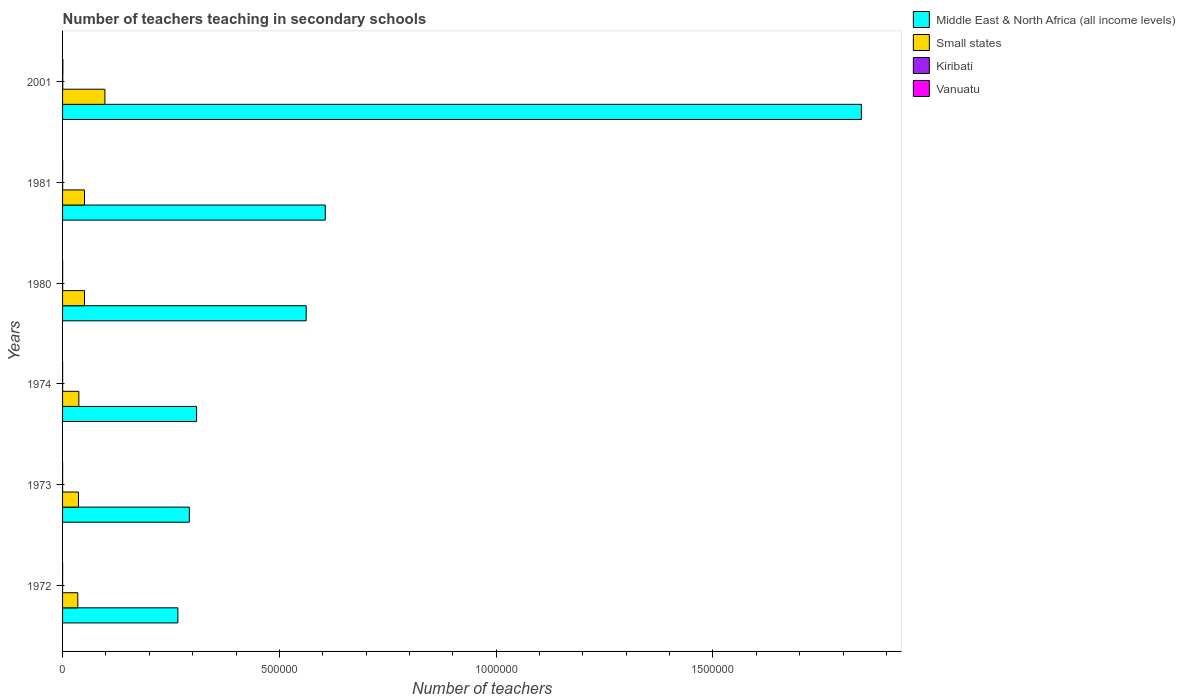How many different coloured bars are there?
Provide a short and direct response. 4. How many bars are there on the 5th tick from the bottom?
Your answer should be compact. 4. In how many cases, is the number of bars for a given year not equal to the number of legend labels?
Ensure brevity in your answer.  0. What is the number of teachers teaching in secondary schools in Middle East & North Africa (all income levels) in 1981?
Give a very brief answer. 6.06e+05. Across all years, what is the maximum number of teachers teaching in secondary schools in Middle East & North Africa (all income levels)?
Make the answer very short. 1.84e+06. Across all years, what is the minimum number of teachers teaching in secondary schools in Small states?
Offer a terse response. 3.51e+04. In which year was the number of teachers teaching in secondary schools in Kiribati minimum?
Offer a very short reply. 1972. What is the total number of teachers teaching in secondary schools in Middle East & North Africa (all income levels) in the graph?
Provide a short and direct response. 3.88e+06. What is the difference between the number of teachers teaching in secondary schools in Kiribati in 1972 and that in 1974?
Give a very brief answer. -10. What is the average number of teachers teaching in secondary schools in Middle East & North Africa (all income levels) per year?
Give a very brief answer. 6.46e+05. In the year 1980, what is the difference between the number of teachers teaching in secondary schools in Vanuatu and number of teachers teaching in secondary schools in Middle East & North Africa (all income levels)?
Ensure brevity in your answer.  -5.62e+05. What is the ratio of the number of teachers teaching in secondary schools in Kiribati in 1972 to that in 1980?
Keep it short and to the point. 0.53. Is the difference between the number of teachers teaching in secondary schools in Vanuatu in 1973 and 1974 greater than the difference between the number of teachers teaching in secondary schools in Middle East & North Africa (all income levels) in 1973 and 1974?
Ensure brevity in your answer.  Yes. What is the difference between the highest and the second highest number of teachers teaching in secondary schools in Middle East & North Africa (all income levels)?
Your answer should be compact. 1.24e+06. What is the difference between the highest and the lowest number of teachers teaching in secondary schools in Kiribati?
Keep it short and to the point. 367. In how many years, is the number of teachers teaching in secondary schools in Middle East & North Africa (all income levels) greater than the average number of teachers teaching in secondary schools in Middle East & North Africa (all income levels) taken over all years?
Your answer should be very brief. 1. What does the 4th bar from the top in 1973 represents?
Keep it short and to the point. Middle East & North Africa (all income levels). What does the 4th bar from the bottom in 1972 represents?
Make the answer very short. Vanuatu. How many bars are there?
Your answer should be compact. 24. Are all the bars in the graph horizontal?
Your answer should be very brief. Yes. How many years are there in the graph?
Your answer should be compact. 6. What is the difference between two consecutive major ticks on the X-axis?
Keep it short and to the point. 5.00e+05. Does the graph contain any zero values?
Give a very brief answer. No. Where does the legend appear in the graph?
Offer a very short reply. Top right. How many legend labels are there?
Keep it short and to the point. 4. What is the title of the graph?
Give a very brief answer. Number of teachers teaching in secondary schools. Does "Ukraine" appear as one of the legend labels in the graph?
Provide a short and direct response. No. What is the label or title of the X-axis?
Offer a terse response. Number of teachers. What is the Number of teachers in Middle East & North Africa (all income levels) in 1972?
Ensure brevity in your answer.  2.66e+05. What is the Number of teachers in Small states in 1972?
Give a very brief answer. 3.51e+04. What is the Number of teachers in Kiribati in 1972?
Provide a short and direct response. 82. What is the Number of teachers of Vanuatu in 1972?
Provide a succinct answer. 113. What is the Number of teachers of Middle East & North Africa (all income levels) in 1973?
Ensure brevity in your answer.  2.92e+05. What is the Number of teachers in Small states in 1973?
Ensure brevity in your answer.  3.67e+04. What is the Number of teachers of Kiribati in 1973?
Your answer should be very brief. 82. What is the Number of teachers in Middle East & North Africa (all income levels) in 1974?
Make the answer very short. 3.09e+05. What is the Number of teachers in Small states in 1974?
Make the answer very short. 3.76e+04. What is the Number of teachers in Kiribati in 1974?
Provide a succinct answer. 92. What is the Number of teachers of Vanuatu in 1974?
Ensure brevity in your answer.  96. What is the Number of teachers of Middle East & North Africa (all income levels) in 1980?
Give a very brief answer. 5.62e+05. What is the Number of teachers of Small states in 1980?
Your answer should be very brief. 5.06e+04. What is the Number of teachers of Kiribati in 1980?
Your answer should be compact. 154. What is the Number of teachers of Vanuatu in 1980?
Offer a very short reply. 185. What is the Number of teachers of Middle East & North Africa (all income levels) in 1981?
Your response must be concise. 6.06e+05. What is the Number of teachers of Small states in 1981?
Provide a short and direct response. 5.06e+04. What is the Number of teachers of Kiribati in 1981?
Provide a short and direct response. 131. What is the Number of teachers of Vanuatu in 1981?
Make the answer very short. 188. What is the Number of teachers of Middle East & North Africa (all income levels) in 2001?
Your answer should be very brief. 1.84e+06. What is the Number of teachers of Small states in 2001?
Your answer should be compact. 9.76e+04. What is the Number of teachers of Kiribati in 2001?
Make the answer very short. 449. What is the Number of teachers of Vanuatu in 2001?
Offer a terse response. 722. Across all years, what is the maximum Number of teachers in Middle East & North Africa (all income levels)?
Provide a short and direct response. 1.84e+06. Across all years, what is the maximum Number of teachers in Small states?
Give a very brief answer. 9.76e+04. Across all years, what is the maximum Number of teachers of Kiribati?
Give a very brief answer. 449. Across all years, what is the maximum Number of teachers of Vanuatu?
Offer a very short reply. 722. Across all years, what is the minimum Number of teachers of Middle East & North Africa (all income levels)?
Provide a short and direct response. 2.66e+05. Across all years, what is the minimum Number of teachers in Small states?
Ensure brevity in your answer.  3.51e+04. Across all years, what is the minimum Number of teachers of Kiribati?
Your response must be concise. 82. What is the total Number of teachers of Middle East & North Africa (all income levels) in the graph?
Make the answer very short. 3.88e+06. What is the total Number of teachers of Small states in the graph?
Provide a short and direct response. 3.08e+05. What is the total Number of teachers in Kiribati in the graph?
Keep it short and to the point. 990. What is the total Number of teachers of Vanuatu in the graph?
Give a very brief answer. 1394. What is the difference between the Number of teachers of Middle East & North Africa (all income levels) in 1972 and that in 1973?
Offer a terse response. -2.65e+04. What is the difference between the Number of teachers of Small states in 1972 and that in 1973?
Make the answer very short. -1541.71. What is the difference between the Number of teachers in Middle East & North Africa (all income levels) in 1972 and that in 1974?
Give a very brief answer. -4.32e+04. What is the difference between the Number of teachers in Small states in 1972 and that in 1974?
Provide a succinct answer. -2455.04. What is the difference between the Number of teachers in Kiribati in 1972 and that in 1974?
Provide a short and direct response. -10. What is the difference between the Number of teachers of Middle East & North Africa (all income levels) in 1972 and that in 1980?
Provide a short and direct response. -2.96e+05. What is the difference between the Number of teachers in Small states in 1972 and that in 1980?
Provide a short and direct response. -1.54e+04. What is the difference between the Number of teachers in Kiribati in 1972 and that in 1980?
Keep it short and to the point. -72. What is the difference between the Number of teachers of Vanuatu in 1972 and that in 1980?
Make the answer very short. -72. What is the difference between the Number of teachers in Middle East & North Africa (all income levels) in 1972 and that in 1981?
Offer a very short reply. -3.40e+05. What is the difference between the Number of teachers in Small states in 1972 and that in 1981?
Offer a very short reply. -1.55e+04. What is the difference between the Number of teachers of Kiribati in 1972 and that in 1981?
Provide a succinct answer. -49. What is the difference between the Number of teachers in Vanuatu in 1972 and that in 1981?
Your answer should be compact. -75. What is the difference between the Number of teachers in Middle East & North Africa (all income levels) in 1972 and that in 2001?
Keep it short and to the point. -1.58e+06. What is the difference between the Number of teachers of Small states in 1972 and that in 2001?
Your response must be concise. -6.25e+04. What is the difference between the Number of teachers in Kiribati in 1972 and that in 2001?
Offer a terse response. -367. What is the difference between the Number of teachers of Vanuatu in 1972 and that in 2001?
Provide a short and direct response. -609. What is the difference between the Number of teachers in Middle East & North Africa (all income levels) in 1973 and that in 1974?
Ensure brevity in your answer.  -1.67e+04. What is the difference between the Number of teachers in Small states in 1973 and that in 1974?
Your answer should be very brief. -913.34. What is the difference between the Number of teachers of Kiribati in 1973 and that in 1974?
Your answer should be very brief. -10. What is the difference between the Number of teachers in Middle East & North Africa (all income levels) in 1973 and that in 1980?
Your answer should be very brief. -2.69e+05. What is the difference between the Number of teachers of Small states in 1973 and that in 1980?
Provide a short and direct response. -1.39e+04. What is the difference between the Number of teachers of Kiribati in 1973 and that in 1980?
Provide a succinct answer. -72. What is the difference between the Number of teachers in Vanuatu in 1973 and that in 1980?
Your answer should be compact. -95. What is the difference between the Number of teachers of Middle East & North Africa (all income levels) in 1973 and that in 1981?
Your answer should be compact. -3.13e+05. What is the difference between the Number of teachers in Small states in 1973 and that in 1981?
Make the answer very short. -1.39e+04. What is the difference between the Number of teachers of Kiribati in 1973 and that in 1981?
Provide a short and direct response. -49. What is the difference between the Number of teachers of Vanuatu in 1973 and that in 1981?
Keep it short and to the point. -98. What is the difference between the Number of teachers in Middle East & North Africa (all income levels) in 1973 and that in 2001?
Your response must be concise. -1.55e+06. What is the difference between the Number of teachers of Small states in 1973 and that in 2001?
Offer a terse response. -6.10e+04. What is the difference between the Number of teachers in Kiribati in 1973 and that in 2001?
Offer a terse response. -367. What is the difference between the Number of teachers in Vanuatu in 1973 and that in 2001?
Make the answer very short. -632. What is the difference between the Number of teachers in Middle East & North Africa (all income levels) in 1974 and that in 1980?
Give a very brief answer. -2.53e+05. What is the difference between the Number of teachers in Small states in 1974 and that in 1980?
Your answer should be compact. -1.30e+04. What is the difference between the Number of teachers of Kiribati in 1974 and that in 1980?
Give a very brief answer. -62. What is the difference between the Number of teachers of Vanuatu in 1974 and that in 1980?
Offer a very short reply. -89. What is the difference between the Number of teachers in Middle East & North Africa (all income levels) in 1974 and that in 1981?
Ensure brevity in your answer.  -2.97e+05. What is the difference between the Number of teachers in Small states in 1974 and that in 1981?
Make the answer very short. -1.30e+04. What is the difference between the Number of teachers in Kiribati in 1974 and that in 1981?
Offer a very short reply. -39. What is the difference between the Number of teachers in Vanuatu in 1974 and that in 1981?
Offer a very short reply. -92. What is the difference between the Number of teachers in Middle East & North Africa (all income levels) in 1974 and that in 2001?
Ensure brevity in your answer.  -1.53e+06. What is the difference between the Number of teachers in Small states in 1974 and that in 2001?
Make the answer very short. -6.01e+04. What is the difference between the Number of teachers of Kiribati in 1974 and that in 2001?
Offer a very short reply. -357. What is the difference between the Number of teachers of Vanuatu in 1974 and that in 2001?
Provide a short and direct response. -626. What is the difference between the Number of teachers in Middle East & North Africa (all income levels) in 1980 and that in 1981?
Your answer should be compact. -4.40e+04. What is the difference between the Number of teachers of Small states in 1980 and that in 1981?
Make the answer very short. -31.36. What is the difference between the Number of teachers of Kiribati in 1980 and that in 1981?
Your answer should be very brief. 23. What is the difference between the Number of teachers in Vanuatu in 1980 and that in 1981?
Provide a short and direct response. -3. What is the difference between the Number of teachers of Middle East & North Africa (all income levels) in 1980 and that in 2001?
Ensure brevity in your answer.  -1.28e+06. What is the difference between the Number of teachers in Small states in 1980 and that in 2001?
Give a very brief answer. -4.71e+04. What is the difference between the Number of teachers in Kiribati in 1980 and that in 2001?
Keep it short and to the point. -295. What is the difference between the Number of teachers in Vanuatu in 1980 and that in 2001?
Make the answer very short. -537. What is the difference between the Number of teachers in Middle East & North Africa (all income levels) in 1981 and that in 2001?
Offer a very short reply. -1.24e+06. What is the difference between the Number of teachers of Small states in 1981 and that in 2001?
Your answer should be compact. -4.71e+04. What is the difference between the Number of teachers of Kiribati in 1981 and that in 2001?
Your response must be concise. -318. What is the difference between the Number of teachers in Vanuatu in 1981 and that in 2001?
Offer a terse response. -534. What is the difference between the Number of teachers in Middle East & North Africa (all income levels) in 1972 and the Number of teachers in Small states in 1973?
Offer a terse response. 2.29e+05. What is the difference between the Number of teachers of Middle East & North Africa (all income levels) in 1972 and the Number of teachers of Kiribati in 1973?
Ensure brevity in your answer.  2.66e+05. What is the difference between the Number of teachers in Middle East & North Africa (all income levels) in 1972 and the Number of teachers in Vanuatu in 1973?
Offer a very short reply. 2.66e+05. What is the difference between the Number of teachers in Small states in 1972 and the Number of teachers in Kiribati in 1973?
Offer a terse response. 3.50e+04. What is the difference between the Number of teachers of Small states in 1972 and the Number of teachers of Vanuatu in 1973?
Provide a succinct answer. 3.50e+04. What is the difference between the Number of teachers in Kiribati in 1972 and the Number of teachers in Vanuatu in 1973?
Offer a very short reply. -8. What is the difference between the Number of teachers in Middle East & North Africa (all income levels) in 1972 and the Number of teachers in Small states in 1974?
Offer a terse response. 2.28e+05. What is the difference between the Number of teachers in Middle East & North Africa (all income levels) in 1972 and the Number of teachers in Kiribati in 1974?
Offer a terse response. 2.66e+05. What is the difference between the Number of teachers of Middle East & North Africa (all income levels) in 1972 and the Number of teachers of Vanuatu in 1974?
Your answer should be compact. 2.66e+05. What is the difference between the Number of teachers of Small states in 1972 and the Number of teachers of Kiribati in 1974?
Offer a very short reply. 3.50e+04. What is the difference between the Number of teachers in Small states in 1972 and the Number of teachers in Vanuatu in 1974?
Your response must be concise. 3.50e+04. What is the difference between the Number of teachers of Middle East & North Africa (all income levels) in 1972 and the Number of teachers of Small states in 1980?
Offer a very short reply. 2.15e+05. What is the difference between the Number of teachers of Middle East & North Africa (all income levels) in 1972 and the Number of teachers of Kiribati in 1980?
Provide a succinct answer. 2.66e+05. What is the difference between the Number of teachers of Middle East & North Africa (all income levels) in 1972 and the Number of teachers of Vanuatu in 1980?
Ensure brevity in your answer.  2.66e+05. What is the difference between the Number of teachers of Small states in 1972 and the Number of teachers of Kiribati in 1980?
Make the answer very short. 3.50e+04. What is the difference between the Number of teachers of Small states in 1972 and the Number of teachers of Vanuatu in 1980?
Give a very brief answer. 3.49e+04. What is the difference between the Number of teachers in Kiribati in 1972 and the Number of teachers in Vanuatu in 1980?
Your answer should be very brief. -103. What is the difference between the Number of teachers of Middle East & North Africa (all income levels) in 1972 and the Number of teachers of Small states in 1981?
Ensure brevity in your answer.  2.15e+05. What is the difference between the Number of teachers of Middle East & North Africa (all income levels) in 1972 and the Number of teachers of Kiribati in 1981?
Ensure brevity in your answer.  2.66e+05. What is the difference between the Number of teachers of Middle East & North Africa (all income levels) in 1972 and the Number of teachers of Vanuatu in 1981?
Give a very brief answer. 2.66e+05. What is the difference between the Number of teachers in Small states in 1972 and the Number of teachers in Kiribati in 1981?
Offer a very short reply. 3.50e+04. What is the difference between the Number of teachers of Small states in 1972 and the Number of teachers of Vanuatu in 1981?
Offer a terse response. 3.49e+04. What is the difference between the Number of teachers in Kiribati in 1972 and the Number of teachers in Vanuatu in 1981?
Provide a short and direct response. -106. What is the difference between the Number of teachers in Middle East & North Africa (all income levels) in 1972 and the Number of teachers in Small states in 2001?
Provide a succinct answer. 1.68e+05. What is the difference between the Number of teachers in Middle East & North Africa (all income levels) in 1972 and the Number of teachers in Kiribati in 2001?
Your answer should be very brief. 2.65e+05. What is the difference between the Number of teachers of Middle East & North Africa (all income levels) in 1972 and the Number of teachers of Vanuatu in 2001?
Offer a very short reply. 2.65e+05. What is the difference between the Number of teachers of Small states in 1972 and the Number of teachers of Kiribati in 2001?
Your answer should be compact. 3.47e+04. What is the difference between the Number of teachers in Small states in 1972 and the Number of teachers in Vanuatu in 2001?
Your answer should be compact. 3.44e+04. What is the difference between the Number of teachers in Kiribati in 1972 and the Number of teachers in Vanuatu in 2001?
Provide a succinct answer. -640. What is the difference between the Number of teachers in Middle East & North Africa (all income levels) in 1973 and the Number of teachers in Small states in 1974?
Ensure brevity in your answer.  2.55e+05. What is the difference between the Number of teachers of Middle East & North Africa (all income levels) in 1973 and the Number of teachers of Kiribati in 1974?
Provide a short and direct response. 2.92e+05. What is the difference between the Number of teachers in Middle East & North Africa (all income levels) in 1973 and the Number of teachers in Vanuatu in 1974?
Provide a succinct answer. 2.92e+05. What is the difference between the Number of teachers of Small states in 1973 and the Number of teachers of Kiribati in 1974?
Give a very brief answer. 3.66e+04. What is the difference between the Number of teachers in Small states in 1973 and the Number of teachers in Vanuatu in 1974?
Your answer should be compact. 3.66e+04. What is the difference between the Number of teachers of Middle East & North Africa (all income levels) in 1973 and the Number of teachers of Small states in 1980?
Keep it short and to the point. 2.42e+05. What is the difference between the Number of teachers in Middle East & North Africa (all income levels) in 1973 and the Number of teachers in Kiribati in 1980?
Ensure brevity in your answer.  2.92e+05. What is the difference between the Number of teachers in Middle East & North Africa (all income levels) in 1973 and the Number of teachers in Vanuatu in 1980?
Your response must be concise. 2.92e+05. What is the difference between the Number of teachers of Small states in 1973 and the Number of teachers of Kiribati in 1980?
Your response must be concise. 3.65e+04. What is the difference between the Number of teachers in Small states in 1973 and the Number of teachers in Vanuatu in 1980?
Give a very brief answer. 3.65e+04. What is the difference between the Number of teachers in Kiribati in 1973 and the Number of teachers in Vanuatu in 1980?
Offer a very short reply. -103. What is the difference between the Number of teachers in Middle East & North Africa (all income levels) in 1973 and the Number of teachers in Small states in 1981?
Your response must be concise. 2.42e+05. What is the difference between the Number of teachers in Middle East & North Africa (all income levels) in 1973 and the Number of teachers in Kiribati in 1981?
Keep it short and to the point. 2.92e+05. What is the difference between the Number of teachers of Middle East & North Africa (all income levels) in 1973 and the Number of teachers of Vanuatu in 1981?
Your response must be concise. 2.92e+05. What is the difference between the Number of teachers in Small states in 1973 and the Number of teachers in Kiribati in 1981?
Your response must be concise. 3.65e+04. What is the difference between the Number of teachers in Small states in 1973 and the Number of teachers in Vanuatu in 1981?
Your answer should be compact. 3.65e+04. What is the difference between the Number of teachers in Kiribati in 1973 and the Number of teachers in Vanuatu in 1981?
Make the answer very short. -106. What is the difference between the Number of teachers of Middle East & North Africa (all income levels) in 1973 and the Number of teachers of Small states in 2001?
Provide a succinct answer. 1.95e+05. What is the difference between the Number of teachers of Middle East & North Africa (all income levels) in 1973 and the Number of teachers of Kiribati in 2001?
Offer a terse response. 2.92e+05. What is the difference between the Number of teachers of Middle East & North Africa (all income levels) in 1973 and the Number of teachers of Vanuatu in 2001?
Make the answer very short. 2.92e+05. What is the difference between the Number of teachers in Small states in 1973 and the Number of teachers in Kiribati in 2001?
Your answer should be compact. 3.62e+04. What is the difference between the Number of teachers in Small states in 1973 and the Number of teachers in Vanuatu in 2001?
Offer a terse response. 3.59e+04. What is the difference between the Number of teachers of Kiribati in 1973 and the Number of teachers of Vanuatu in 2001?
Provide a short and direct response. -640. What is the difference between the Number of teachers in Middle East & North Africa (all income levels) in 1974 and the Number of teachers in Small states in 1980?
Your answer should be compact. 2.59e+05. What is the difference between the Number of teachers in Middle East & North Africa (all income levels) in 1974 and the Number of teachers in Kiribati in 1980?
Keep it short and to the point. 3.09e+05. What is the difference between the Number of teachers in Middle East & North Africa (all income levels) in 1974 and the Number of teachers in Vanuatu in 1980?
Your answer should be compact. 3.09e+05. What is the difference between the Number of teachers in Small states in 1974 and the Number of teachers in Kiribati in 1980?
Make the answer very short. 3.74e+04. What is the difference between the Number of teachers in Small states in 1974 and the Number of teachers in Vanuatu in 1980?
Your answer should be compact. 3.74e+04. What is the difference between the Number of teachers in Kiribati in 1974 and the Number of teachers in Vanuatu in 1980?
Provide a succinct answer. -93. What is the difference between the Number of teachers in Middle East & North Africa (all income levels) in 1974 and the Number of teachers in Small states in 1981?
Your answer should be very brief. 2.59e+05. What is the difference between the Number of teachers in Middle East & North Africa (all income levels) in 1974 and the Number of teachers in Kiribati in 1981?
Offer a very short reply. 3.09e+05. What is the difference between the Number of teachers in Middle East & North Africa (all income levels) in 1974 and the Number of teachers in Vanuatu in 1981?
Give a very brief answer. 3.09e+05. What is the difference between the Number of teachers of Small states in 1974 and the Number of teachers of Kiribati in 1981?
Give a very brief answer. 3.74e+04. What is the difference between the Number of teachers of Small states in 1974 and the Number of teachers of Vanuatu in 1981?
Offer a very short reply. 3.74e+04. What is the difference between the Number of teachers of Kiribati in 1974 and the Number of teachers of Vanuatu in 1981?
Offer a terse response. -96. What is the difference between the Number of teachers of Middle East & North Africa (all income levels) in 1974 and the Number of teachers of Small states in 2001?
Your response must be concise. 2.11e+05. What is the difference between the Number of teachers in Middle East & North Africa (all income levels) in 1974 and the Number of teachers in Kiribati in 2001?
Make the answer very short. 3.09e+05. What is the difference between the Number of teachers in Middle East & North Africa (all income levels) in 1974 and the Number of teachers in Vanuatu in 2001?
Offer a very short reply. 3.08e+05. What is the difference between the Number of teachers in Small states in 1974 and the Number of teachers in Kiribati in 2001?
Offer a terse response. 3.71e+04. What is the difference between the Number of teachers of Small states in 1974 and the Number of teachers of Vanuatu in 2001?
Provide a succinct answer. 3.69e+04. What is the difference between the Number of teachers of Kiribati in 1974 and the Number of teachers of Vanuatu in 2001?
Provide a succinct answer. -630. What is the difference between the Number of teachers in Middle East & North Africa (all income levels) in 1980 and the Number of teachers in Small states in 1981?
Your response must be concise. 5.11e+05. What is the difference between the Number of teachers of Middle East & North Africa (all income levels) in 1980 and the Number of teachers of Kiribati in 1981?
Give a very brief answer. 5.62e+05. What is the difference between the Number of teachers of Middle East & North Africa (all income levels) in 1980 and the Number of teachers of Vanuatu in 1981?
Your answer should be compact. 5.62e+05. What is the difference between the Number of teachers in Small states in 1980 and the Number of teachers in Kiribati in 1981?
Offer a very short reply. 5.04e+04. What is the difference between the Number of teachers of Small states in 1980 and the Number of teachers of Vanuatu in 1981?
Offer a terse response. 5.04e+04. What is the difference between the Number of teachers of Kiribati in 1980 and the Number of teachers of Vanuatu in 1981?
Ensure brevity in your answer.  -34. What is the difference between the Number of teachers of Middle East & North Africa (all income levels) in 1980 and the Number of teachers of Small states in 2001?
Your answer should be compact. 4.64e+05. What is the difference between the Number of teachers in Middle East & North Africa (all income levels) in 1980 and the Number of teachers in Kiribati in 2001?
Offer a terse response. 5.61e+05. What is the difference between the Number of teachers in Middle East & North Africa (all income levels) in 1980 and the Number of teachers in Vanuatu in 2001?
Your answer should be compact. 5.61e+05. What is the difference between the Number of teachers in Small states in 1980 and the Number of teachers in Kiribati in 2001?
Your response must be concise. 5.01e+04. What is the difference between the Number of teachers in Small states in 1980 and the Number of teachers in Vanuatu in 2001?
Ensure brevity in your answer.  4.98e+04. What is the difference between the Number of teachers in Kiribati in 1980 and the Number of teachers in Vanuatu in 2001?
Provide a short and direct response. -568. What is the difference between the Number of teachers in Middle East & North Africa (all income levels) in 1981 and the Number of teachers in Small states in 2001?
Ensure brevity in your answer.  5.08e+05. What is the difference between the Number of teachers in Middle East & North Africa (all income levels) in 1981 and the Number of teachers in Kiribati in 2001?
Your answer should be very brief. 6.05e+05. What is the difference between the Number of teachers of Middle East & North Africa (all income levels) in 1981 and the Number of teachers of Vanuatu in 2001?
Ensure brevity in your answer.  6.05e+05. What is the difference between the Number of teachers of Small states in 1981 and the Number of teachers of Kiribati in 2001?
Offer a very short reply. 5.01e+04. What is the difference between the Number of teachers of Small states in 1981 and the Number of teachers of Vanuatu in 2001?
Ensure brevity in your answer.  4.99e+04. What is the difference between the Number of teachers of Kiribati in 1981 and the Number of teachers of Vanuatu in 2001?
Provide a succinct answer. -591. What is the average Number of teachers of Middle East & North Africa (all income levels) per year?
Your answer should be compact. 6.46e+05. What is the average Number of teachers of Small states per year?
Ensure brevity in your answer.  5.14e+04. What is the average Number of teachers of Kiribati per year?
Ensure brevity in your answer.  165. What is the average Number of teachers of Vanuatu per year?
Offer a very short reply. 232.33. In the year 1972, what is the difference between the Number of teachers of Middle East & North Africa (all income levels) and Number of teachers of Small states?
Your answer should be very brief. 2.31e+05. In the year 1972, what is the difference between the Number of teachers in Middle East & North Africa (all income levels) and Number of teachers in Kiribati?
Keep it short and to the point. 2.66e+05. In the year 1972, what is the difference between the Number of teachers of Middle East & North Africa (all income levels) and Number of teachers of Vanuatu?
Keep it short and to the point. 2.66e+05. In the year 1972, what is the difference between the Number of teachers in Small states and Number of teachers in Kiribati?
Offer a very short reply. 3.50e+04. In the year 1972, what is the difference between the Number of teachers in Small states and Number of teachers in Vanuatu?
Ensure brevity in your answer.  3.50e+04. In the year 1972, what is the difference between the Number of teachers in Kiribati and Number of teachers in Vanuatu?
Your answer should be compact. -31. In the year 1973, what is the difference between the Number of teachers in Middle East & North Africa (all income levels) and Number of teachers in Small states?
Offer a very short reply. 2.56e+05. In the year 1973, what is the difference between the Number of teachers in Middle East & North Africa (all income levels) and Number of teachers in Kiribati?
Provide a succinct answer. 2.92e+05. In the year 1973, what is the difference between the Number of teachers in Middle East & North Africa (all income levels) and Number of teachers in Vanuatu?
Offer a very short reply. 2.92e+05. In the year 1973, what is the difference between the Number of teachers of Small states and Number of teachers of Kiribati?
Make the answer very short. 3.66e+04. In the year 1973, what is the difference between the Number of teachers in Small states and Number of teachers in Vanuatu?
Your answer should be compact. 3.66e+04. In the year 1973, what is the difference between the Number of teachers in Kiribati and Number of teachers in Vanuatu?
Your answer should be very brief. -8. In the year 1974, what is the difference between the Number of teachers in Middle East & North Africa (all income levels) and Number of teachers in Small states?
Your answer should be compact. 2.72e+05. In the year 1974, what is the difference between the Number of teachers in Middle East & North Africa (all income levels) and Number of teachers in Kiribati?
Your response must be concise. 3.09e+05. In the year 1974, what is the difference between the Number of teachers of Middle East & North Africa (all income levels) and Number of teachers of Vanuatu?
Make the answer very short. 3.09e+05. In the year 1974, what is the difference between the Number of teachers in Small states and Number of teachers in Kiribati?
Offer a terse response. 3.75e+04. In the year 1974, what is the difference between the Number of teachers in Small states and Number of teachers in Vanuatu?
Your answer should be compact. 3.75e+04. In the year 1980, what is the difference between the Number of teachers of Middle East & North Africa (all income levels) and Number of teachers of Small states?
Give a very brief answer. 5.11e+05. In the year 1980, what is the difference between the Number of teachers in Middle East & North Africa (all income levels) and Number of teachers in Kiribati?
Offer a very short reply. 5.62e+05. In the year 1980, what is the difference between the Number of teachers of Middle East & North Africa (all income levels) and Number of teachers of Vanuatu?
Your response must be concise. 5.62e+05. In the year 1980, what is the difference between the Number of teachers in Small states and Number of teachers in Kiribati?
Provide a short and direct response. 5.04e+04. In the year 1980, what is the difference between the Number of teachers in Small states and Number of teachers in Vanuatu?
Offer a very short reply. 5.04e+04. In the year 1980, what is the difference between the Number of teachers in Kiribati and Number of teachers in Vanuatu?
Ensure brevity in your answer.  -31. In the year 1981, what is the difference between the Number of teachers of Middle East & North Africa (all income levels) and Number of teachers of Small states?
Ensure brevity in your answer.  5.55e+05. In the year 1981, what is the difference between the Number of teachers in Middle East & North Africa (all income levels) and Number of teachers in Kiribati?
Offer a very short reply. 6.06e+05. In the year 1981, what is the difference between the Number of teachers of Middle East & North Africa (all income levels) and Number of teachers of Vanuatu?
Provide a short and direct response. 6.06e+05. In the year 1981, what is the difference between the Number of teachers in Small states and Number of teachers in Kiribati?
Provide a succinct answer. 5.05e+04. In the year 1981, what is the difference between the Number of teachers of Small states and Number of teachers of Vanuatu?
Ensure brevity in your answer.  5.04e+04. In the year 1981, what is the difference between the Number of teachers of Kiribati and Number of teachers of Vanuatu?
Offer a terse response. -57. In the year 2001, what is the difference between the Number of teachers of Middle East & North Africa (all income levels) and Number of teachers of Small states?
Your response must be concise. 1.74e+06. In the year 2001, what is the difference between the Number of teachers of Middle East & North Africa (all income levels) and Number of teachers of Kiribati?
Give a very brief answer. 1.84e+06. In the year 2001, what is the difference between the Number of teachers of Middle East & North Africa (all income levels) and Number of teachers of Vanuatu?
Make the answer very short. 1.84e+06. In the year 2001, what is the difference between the Number of teachers in Small states and Number of teachers in Kiribati?
Offer a very short reply. 9.72e+04. In the year 2001, what is the difference between the Number of teachers in Small states and Number of teachers in Vanuatu?
Your response must be concise. 9.69e+04. In the year 2001, what is the difference between the Number of teachers in Kiribati and Number of teachers in Vanuatu?
Provide a short and direct response. -273. What is the ratio of the Number of teachers in Middle East & North Africa (all income levels) in 1972 to that in 1973?
Provide a succinct answer. 0.91. What is the ratio of the Number of teachers in Small states in 1972 to that in 1973?
Your response must be concise. 0.96. What is the ratio of the Number of teachers of Vanuatu in 1972 to that in 1973?
Provide a succinct answer. 1.26. What is the ratio of the Number of teachers in Middle East & North Africa (all income levels) in 1972 to that in 1974?
Provide a succinct answer. 0.86. What is the ratio of the Number of teachers of Small states in 1972 to that in 1974?
Keep it short and to the point. 0.93. What is the ratio of the Number of teachers of Kiribati in 1972 to that in 1974?
Make the answer very short. 0.89. What is the ratio of the Number of teachers in Vanuatu in 1972 to that in 1974?
Provide a succinct answer. 1.18. What is the ratio of the Number of teachers in Middle East & North Africa (all income levels) in 1972 to that in 1980?
Ensure brevity in your answer.  0.47. What is the ratio of the Number of teachers in Small states in 1972 to that in 1980?
Offer a terse response. 0.69. What is the ratio of the Number of teachers of Kiribati in 1972 to that in 1980?
Ensure brevity in your answer.  0.53. What is the ratio of the Number of teachers of Vanuatu in 1972 to that in 1980?
Offer a terse response. 0.61. What is the ratio of the Number of teachers of Middle East & North Africa (all income levels) in 1972 to that in 1981?
Provide a short and direct response. 0.44. What is the ratio of the Number of teachers of Small states in 1972 to that in 1981?
Provide a short and direct response. 0.69. What is the ratio of the Number of teachers of Kiribati in 1972 to that in 1981?
Offer a terse response. 0.63. What is the ratio of the Number of teachers in Vanuatu in 1972 to that in 1981?
Ensure brevity in your answer.  0.6. What is the ratio of the Number of teachers of Middle East & North Africa (all income levels) in 1972 to that in 2001?
Provide a short and direct response. 0.14. What is the ratio of the Number of teachers of Small states in 1972 to that in 2001?
Your answer should be very brief. 0.36. What is the ratio of the Number of teachers in Kiribati in 1972 to that in 2001?
Provide a short and direct response. 0.18. What is the ratio of the Number of teachers in Vanuatu in 1972 to that in 2001?
Offer a very short reply. 0.16. What is the ratio of the Number of teachers of Middle East & North Africa (all income levels) in 1973 to that in 1974?
Ensure brevity in your answer.  0.95. What is the ratio of the Number of teachers of Small states in 1973 to that in 1974?
Your response must be concise. 0.98. What is the ratio of the Number of teachers in Kiribati in 1973 to that in 1974?
Make the answer very short. 0.89. What is the ratio of the Number of teachers of Middle East & North Africa (all income levels) in 1973 to that in 1980?
Keep it short and to the point. 0.52. What is the ratio of the Number of teachers of Small states in 1973 to that in 1980?
Offer a terse response. 0.73. What is the ratio of the Number of teachers of Kiribati in 1973 to that in 1980?
Make the answer very short. 0.53. What is the ratio of the Number of teachers of Vanuatu in 1973 to that in 1980?
Offer a very short reply. 0.49. What is the ratio of the Number of teachers in Middle East & North Africa (all income levels) in 1973 to that in 1981?
Give a very brief answer. 0.48. What is the ratio of the Number of teachers in Small states in 1973 to that in 1981?
Give a very brief answer. 0.72. What is the ratio of the Number of teachers of Kiribati in 1973 to that in 1981?
Your answer should be compact. 0.63. What is the ratio of the Number of teachers in Vanuatu in 1973 to that in 1981?
Provide a succinct answer. 0.48. What is the ratio of the Number of teachers in Middle East & North Africa (all income levels) in 1973 to that in 2001?
Provide a succinct answer. 0.16. What is the ratio of the Number of teachers of Small states in 1973 to that in 2001?
Your answer should be compact. 0.38. What is the ratio of the Number of teachers in Kiribati in 1973 to that in 2001?
Give a very brief answer. 0.18. What is the ratio of the Number of teachers in Vanuatu in 1973 to that in 2001?
Keep it short and to the point. 0.12. What is the ratio of the Number of teachers in Middle East & North Africa (all income levels) in 1974 to that in 1980?
Give a very brief answer. 0.55. What is the ratio of the Number of teachers in Small states in 1974 to that in 1980?
Offer a very short reply. 0.74. What is the ratio of the Number of teachers in Kiribati in 1974 to that in 1980?
Provide a short and direct response. 0.6. What is the ratio of the Number of teachers in Vanuatu in 1974 to that in 1980?
Your answer should be very brief. 0.52. What is the ratio of the Number of teachers in Middle East & North Africa (all income levels) in 1974 to that in 1981?
Your answer should be compact. 0.51. What is the ratio of the Number of teachers in Small states in 1974 to that in 1981?
Your answer should be very brief. 0.74. What is the ratio of the Number of teachers of Kiribati in 1974 to that in 1981?
Your answer should be very brief. 0.7. What is the ratio of the Number of teachers in Vanuatu in 1974 to that in 1981?
Offer a terse response. 0.51. What is the ratio of the Number of teachers in Middle East & North Africa (all income levels) in 1974 to that in 2001?
Your answer should be very brief. 0.17. What is the ratio of the Number of teachers of Small states in 1974 to that in 2001?
Your response must be concise. 0.38. What is the ratio of the Number of teachers of Kiribati in 1974 to that in 2001?
Ensure brevity in your answer.  0.2. What is the ratio of the Number of teachers of Vanuatu in 1974 to that in 2001?
Offer a very short reply. 0.13. What is the ratio of the Number of teachers of Middle East & North Africa (all income levels) in 1980 to that in 1981?
Give a very brief answer. 0.93. What is the ratio of the Number of teachers of Kiribati in 1980 to that in 1981?
Offer a terse response. 1.18. What is the ratio of the Number of teachers in Vanuatu in 1980 to that in 1981?
Your answer should be compact. 0.98. What is the ratio of the Number of teachers in Middle East & North Africa (all income levels) in 1980 to that in 2001?
Provide a succinct answer. 0.3. What is the ratio of the Number of teachers of Small states in 1980 to that in 2001?
Give a very brief answer. 0.52. What is the ratio of the Number of teachers of Kiribati in 1980 to that in 2001?
Your answer should be very brief. 0.34. What is the ratio of the Number of teachers in Vanuatu in 1980 to that in 2001?
Your answer should be compact. 0.26. What is the ratio of the Number of teachers of Middle East & North Africa (all income levels) in 1981 to that in 2001?
Offer a terse response. 0.33. What is the ratio of the Number of teachers in Small states in 1981 to that in 2001?
Your answer should be very brief. 0.52. What is the ratio of the Number of teachers of Kiribati in 1981 to that in 2001?
Make the answer very short. 0.29. What is the ratio of the Number of teachers of Vanuatu in 1981 to that in 2001?
Provide a short and direct response. 0.26. What is the difference between the highest and the second highest Number of teachers in Middle East & North Africa (all income levels)?
Offer a terse response. 1.24e+06. What is the difference between the highest and the second highest Number of teachers in Small states?
Your response must be concise. 4.71e+04. What is the difference between the highest and the second highest Number of teachers in Kiribati?
Your answer should be compact. 295. What is the difference between the highest and the second highest Number of teachers of Vanuatu?
Ensure brevity in your answer.  534. What is the difference between the highest and the lowest Number of teachers in Middle East & North Africa (all income levels)?
Give a very brief answer. 1.58e+06. What is the difference between the highest and the lowest Number of teachers in Small states?
Offer a very short reply. 6.25e+04. What is the difference between the highest and the lowest Number of teachers in Kiribati?
Make the answer very short. 367. What is the difference between the highest and the lowest Number of teachers in Vanuatu?
Ensure brevity in your answer.  632. 